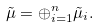<formula> <loc_0><loc_0><loc_500><loc_500>\tilde { \mu } = \oplus _ { i = 1 } ^ { n } \tilde { \mu } _ { i } .</formula> 